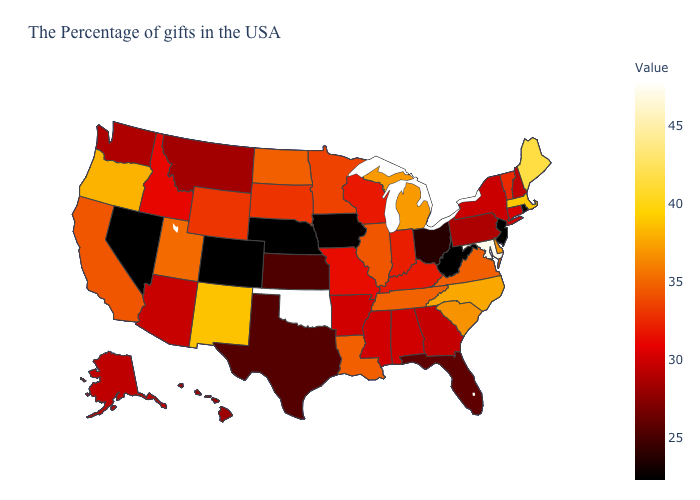Which states hav the highest value in the West?
Quick response, please. New Mexico. Does Minnesota have the highest value in the MidWest?
Write a very short answer. No. Is the legend a continuous bar?
Write a very short answer. Yes. Does Nebraska have the lowest value in the USA?
Concise answer only. Yes. Among the states that border Florida , does Georgia have the lowest value?
Write a very short answer. Yes. Is the legend a continuous bar?
Give a very brief answer. Yes. Which states have the highest value in the USA?
Answer briefly. Oklahoma. 